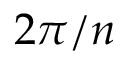<formula> <loc_0><loc_0><loc_500><loc_500>2 \pi / n</formula> 